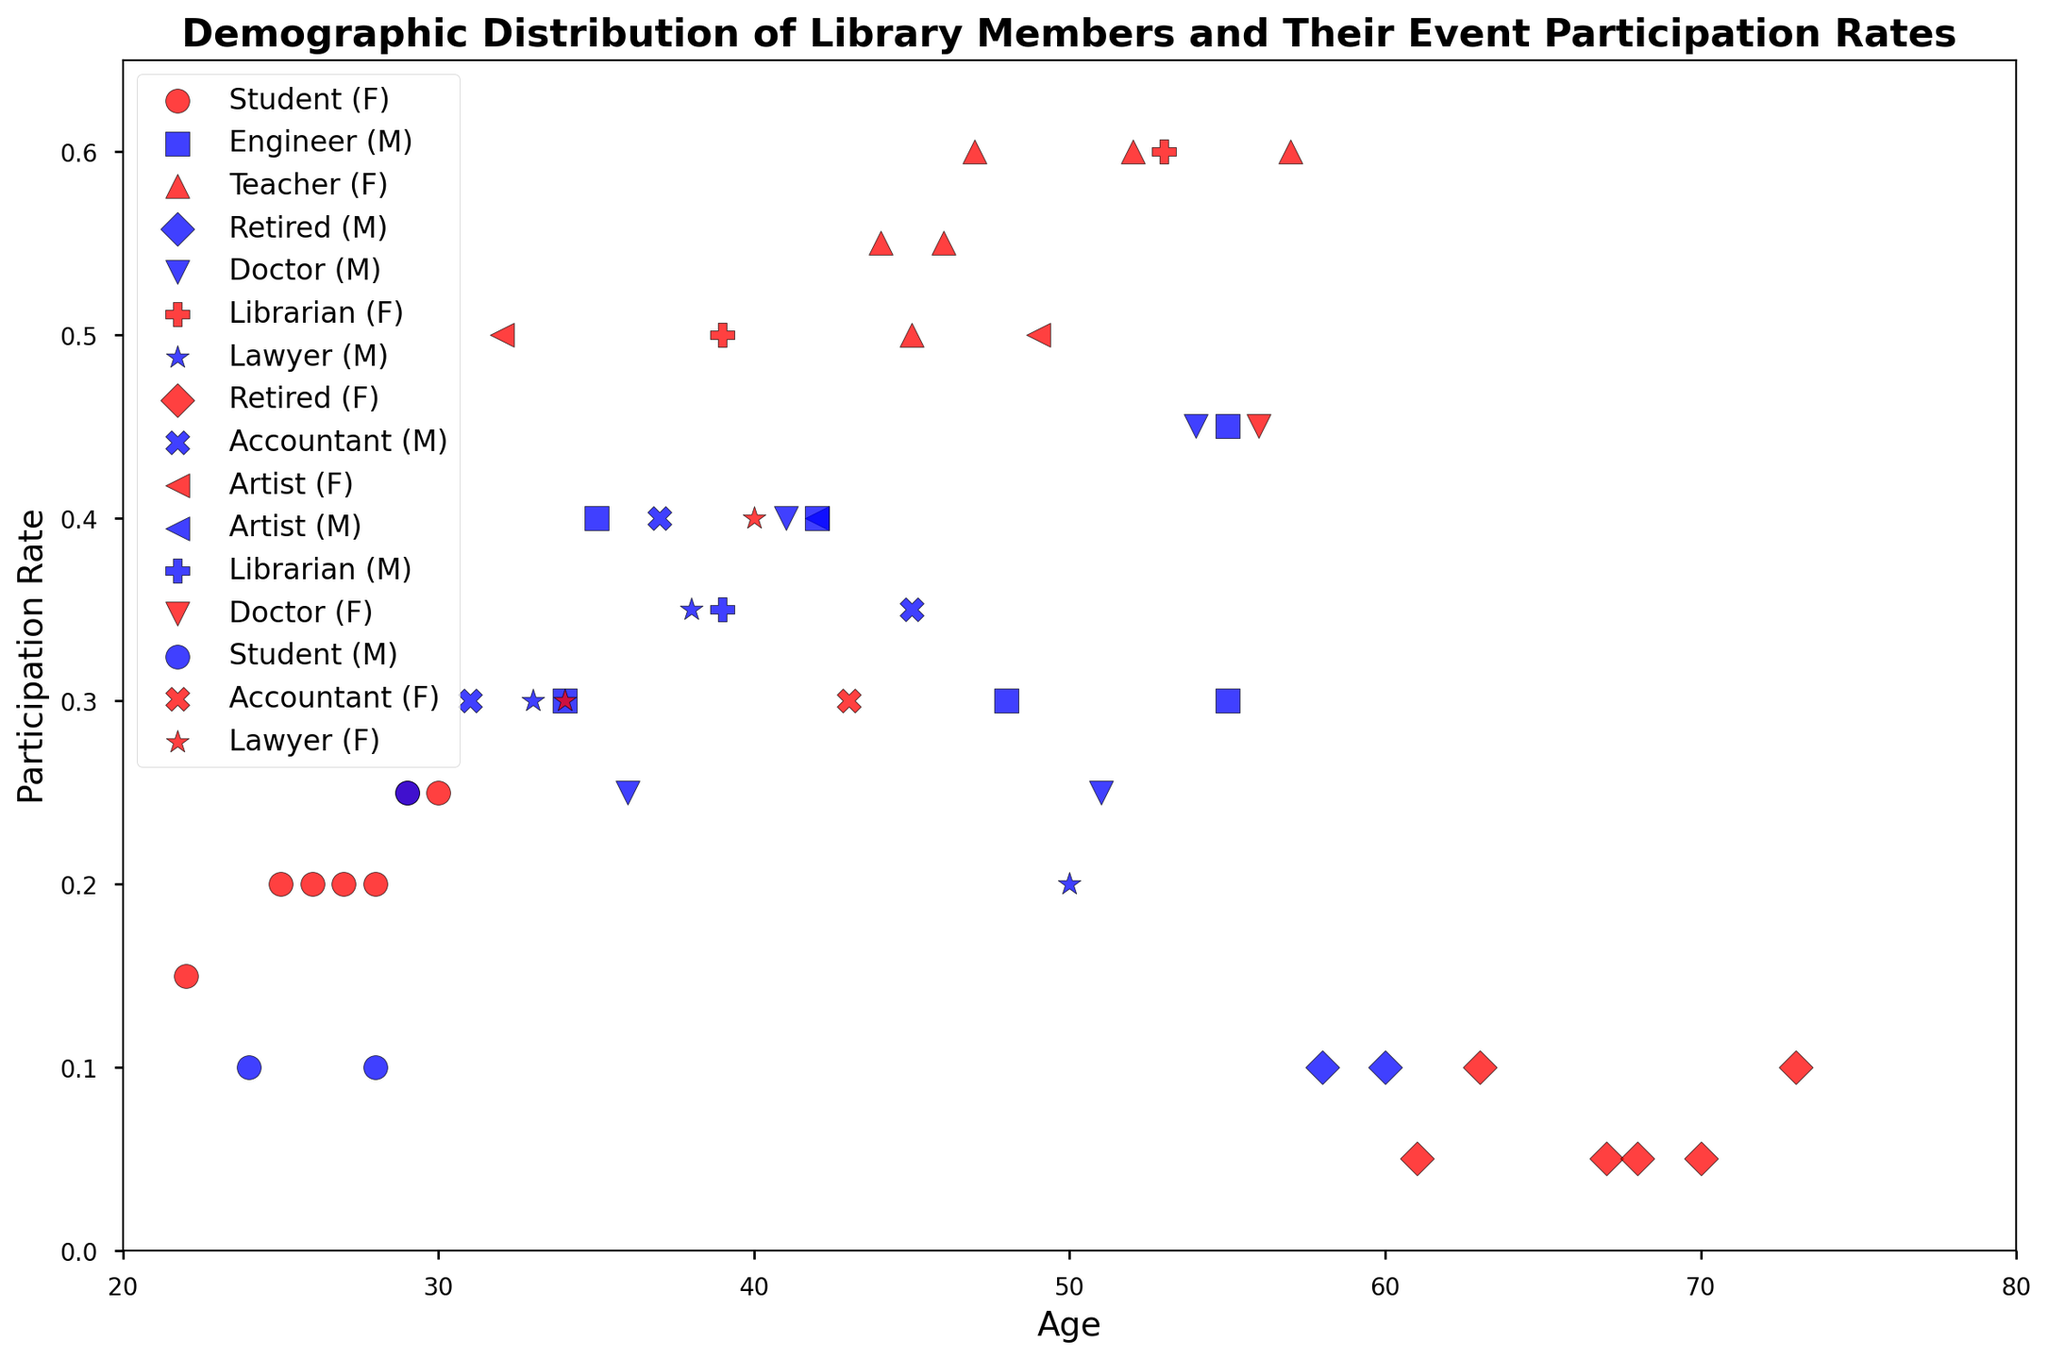What are the average ages of male and female library members? To find the average age of male and female members, first, sum the ages of all male members and divide by the number of male members, then do the same for female members. Here’s the computation:
Average age of males = (34 + 60 + 41 + 38 + 22 + 36 + 33 + 54 + 28 + 43 + 70 + 39) / 12 = 45.0833.
Average age of females = (25 + 45 + 29 + 22 + 31 + 44 + 55 + 19 + 26 + 28 + 67 + 50) / 12 = 36.8333.
Therefore, the average ages are:
Male: 45.08
Female: 36.83
Answer: Male: 45.08, Female: 36.83 Which occupation has the highest participation rate? Inspect the y-axis values and markers in the plot. Notice that the librarian category (marked with 'P') mostly occupies the highest values. Specifically, there are multiple librarians with participation rates around 0.6.
Answer: Librarian How does the participation rate of students compare to that of retired members? Identify the markers for students ('o') and retired members ('D'). Observing the y-axis values, most students have participation rates between 0.1 and 0.25, whereas retired members are consistently at 0.05 or 0.1.
Answer: Students generally have higher participation rates than retired members What's the difference between the highest and lowest participation rates? Identify the highest point and the lowest point on the y-axis. The highest participation rate is approximately 0.6, mostly indicated by teachers and librarians, while the lowest rate is around 0.05 for retired members. The difference is calculated as 0.6 - 0.05 = 0.55.
Answer: 0.55 Are there more male or female library members? Observe the colors representing genders. Count the blue markers representing males and the red markers representing females.
According to the data, there are 20 males and 30 females.
Answer: Female What is the median participation rate for teachers? Identify the markers for teachers ('^'). There are six data points for teachers: 0.5, 0.55, 0.6, 0.6, 0.55, and 0.6. Ordering these from smallest to largest: 0.5, 0.55, 0.55, 0.6, 0.6, 0.6. The median participation rate is the average of the 3rd and 4th values: (0.55 + 0.6) / 2 = 0.575.
Answer: 0.575 Which age group, students or librarians, show more variation in participation rates? Examine the spread of the markers for students ('o') and librarians ('P'). Students have participation rates from 0.1 to 0.25, whereas librarians range from 0.35 to 0.6. The spread (range) for students is 0.25 - 0.1 = 0.15, and for librarians is 0.6 - 0.35 = 0.25. Therefore, librarians show more variation.
Answer: Librarians Which group has the highest concentration of members within the age range of 30-40? Identify the markers within the age range of 30-40 and count how many members each occupation has within this range. The group with the highest count within this range is most concentrated. The students and accountants groups both have a notable presence, but students have slightly more individuals.
Answer: Students 